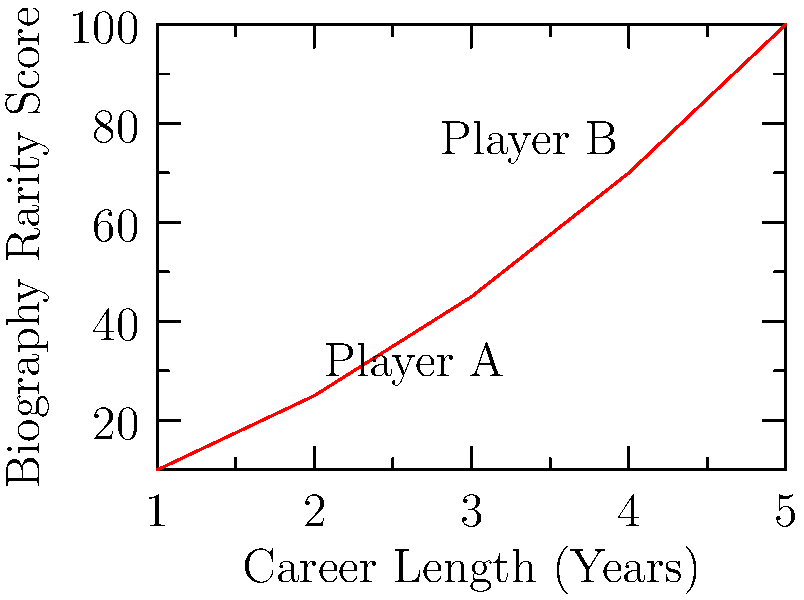Based on the graph showing the relationship between a player's career length and their biography's rarity score, what factor likely contributes most to the increasing rarity of a player's biography as their career progresses? To answer this question, let's analyze the graph step-by-step:

1. The x-axis represents the player's career length in years.
2. The y-axis represents the biography rarity score.
3. We can see a clear positive correlation between career length and rarity score.
4. The curve is not linear but shows an exponential growth pattern.
5. This suggests that as a player's career lengthens, their biography becomes disproportionately rarer.
6. Longer careers typically involve:
   a) More achievements and records
   b) Greater fan following
   c) More memorable moments and stories
7. These factors contribute to a player's legacy and make their biography more desirable.
8. The exponential growth implies that each additional year adds significantly more value to the biography's rarity.
9. This is likely due to the cumulative effect of achievements and the increased likelihood of reaching major milestones.

Given this analysis, the factor that likely contributes most to the increasing rarity of a player's biography as their career progresses is the accumulation of achievements, records, and memorable moments over time.
Answer: Accumulation of achievements and records over time 